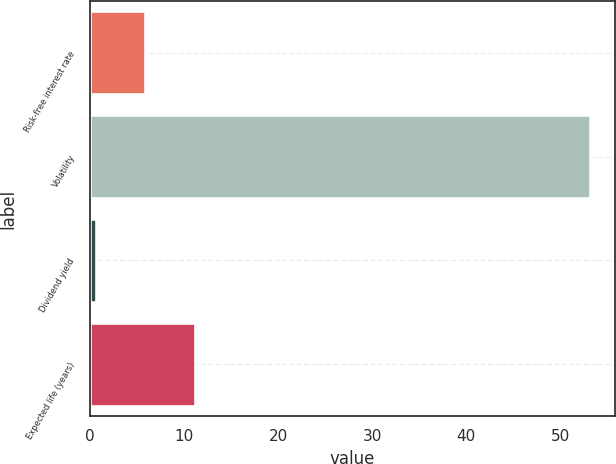Convert chart to OTSL. <chart><loc_0><loc_0><loc_500><loc_500><bar_chart><fcel>Risk-free interest rate<fcel>Volatility<fcel>Dividend yield<fcel>Expected life (years)<nl><fcel>5.86<fcel>53.2<fcel>0.6<fcel>11.12<nl></chart> 